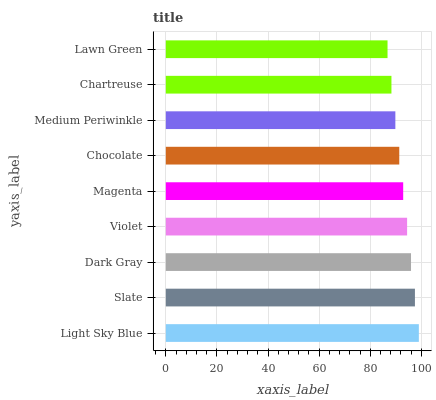Is Lawn Green the minimum?
Answer yes or no. Yes. Is Light Sky Blue the maximum?
Answer yes or no. Yes. Is Slate the minimum?
Answer yes or no. No. Is Slate the maximum?
Answer yes or no. No. Is Light Sky Blue greater than Slate?
Answer yes or no. Yes. Is Slate less than Light Sky Blue?
Answer yes or no. Yes. Is Slate greater than Light Sky Blue?
Answer yes or no. No. Is Light Sky Blue less than Slate?
Answer yes or no. No. Is Magenta the high median?
Answer yes or no. Yes. Is Magenta the low median?
Answer yes or no. Yes. Is Chartreuse the high median?
Answer yes or no. No. Is Slate the low median?
Answer yes or no. No. 